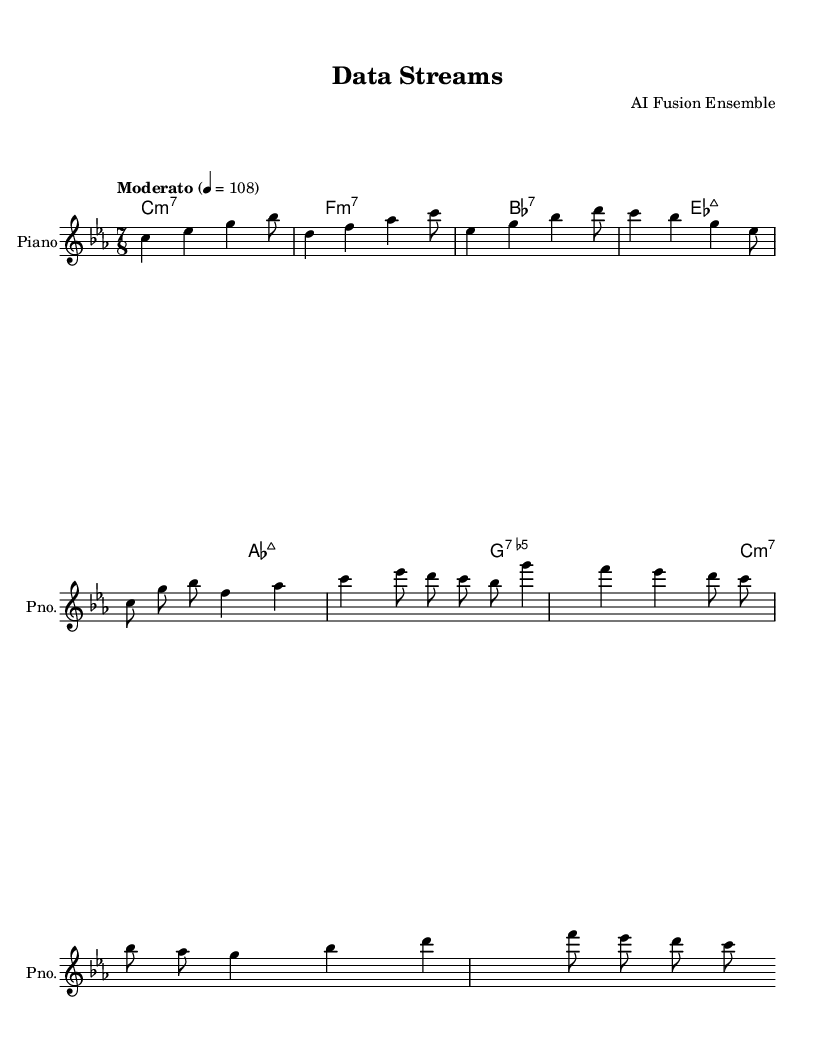What is the key signature of this music? The key signature is C minor, which contains three flats: B flat, E flat, and A flat. This can be determined by looking at the key signature indicated at the beginning of the score.
Answer: C minor What is the time signature of this piece? The time signature is 7/8, indicated at the beginning of the score. This means there are seven eighth note beats in each measure.
Answer: 7/8 What is the tempo marking for this piece? The tempo marking is "Moderato" with a metronome marking of quarter note equals 108. This can be identified in the tempo indication given in the score.
Answer: Moderato How many measures are there in Theme A? Theme A consists of three measures. By counting the measures from the start of the Theme A section, we can determine the total.
Answer: 3 What is the first chord in the harmony section? The first chord in the harmony section is C minor 7. This can be found by reading the chord names listed in the ChordNames section, with the first one being notated as "c1:m7".
Answer: C minor 7 Which theme has a descending melodic contour? Theme B has a descending melodic contour, as indicated by the notes moving downwards in pitch throughout its progression. One can observe the series of notes to affirm the downward trend.
Answer: Theme B 